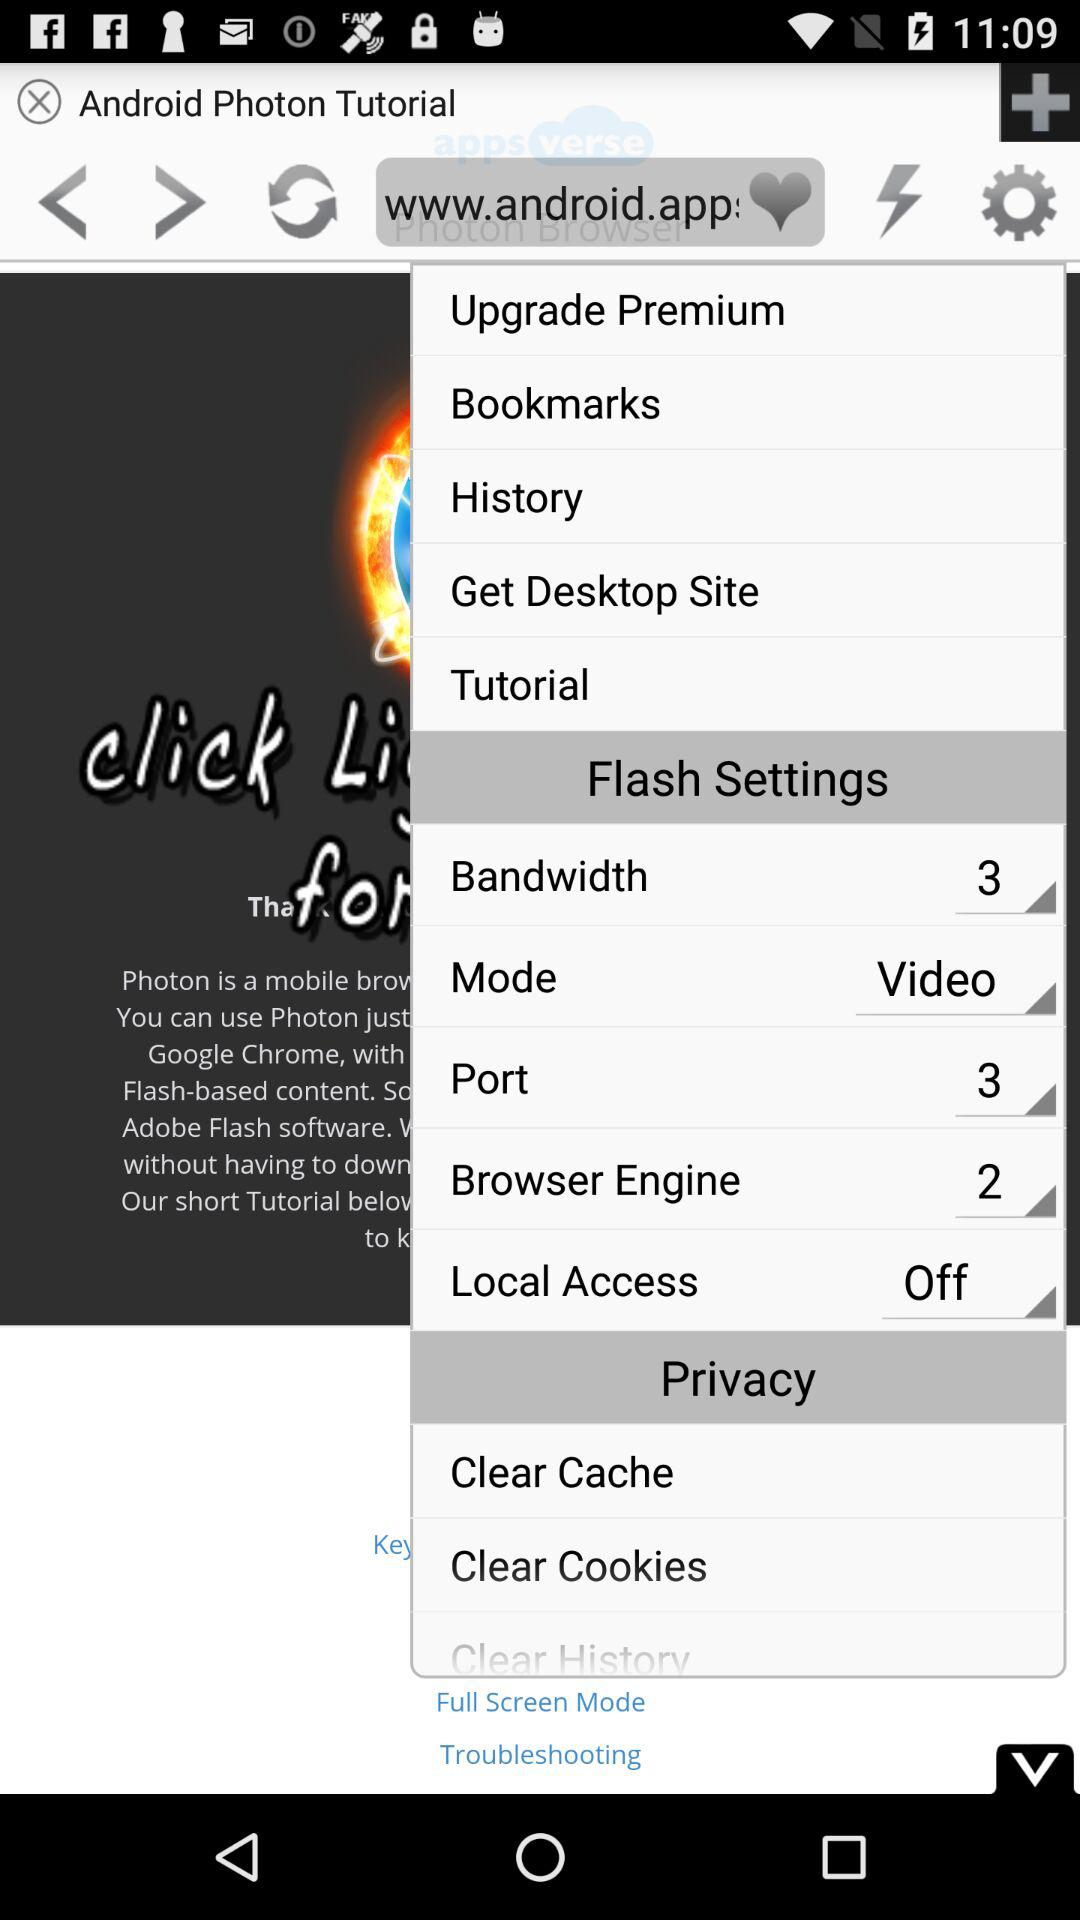What is the mode? The mode is "Video". 